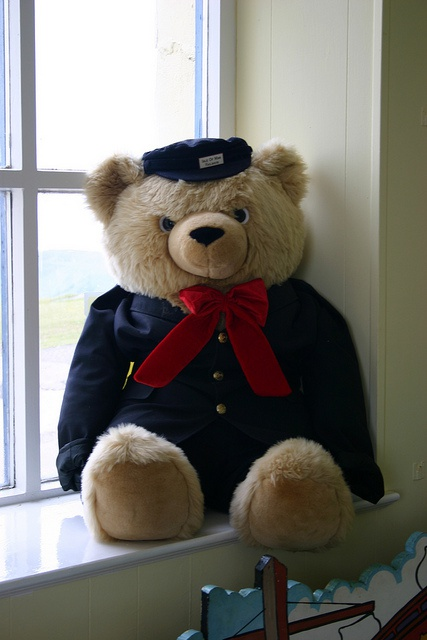Describe the objects in this image and their specific colors. I can see teddy bear in lavender, black, maroon, and gray tones and tie in lavender, maroon, and brown tones in this image. 